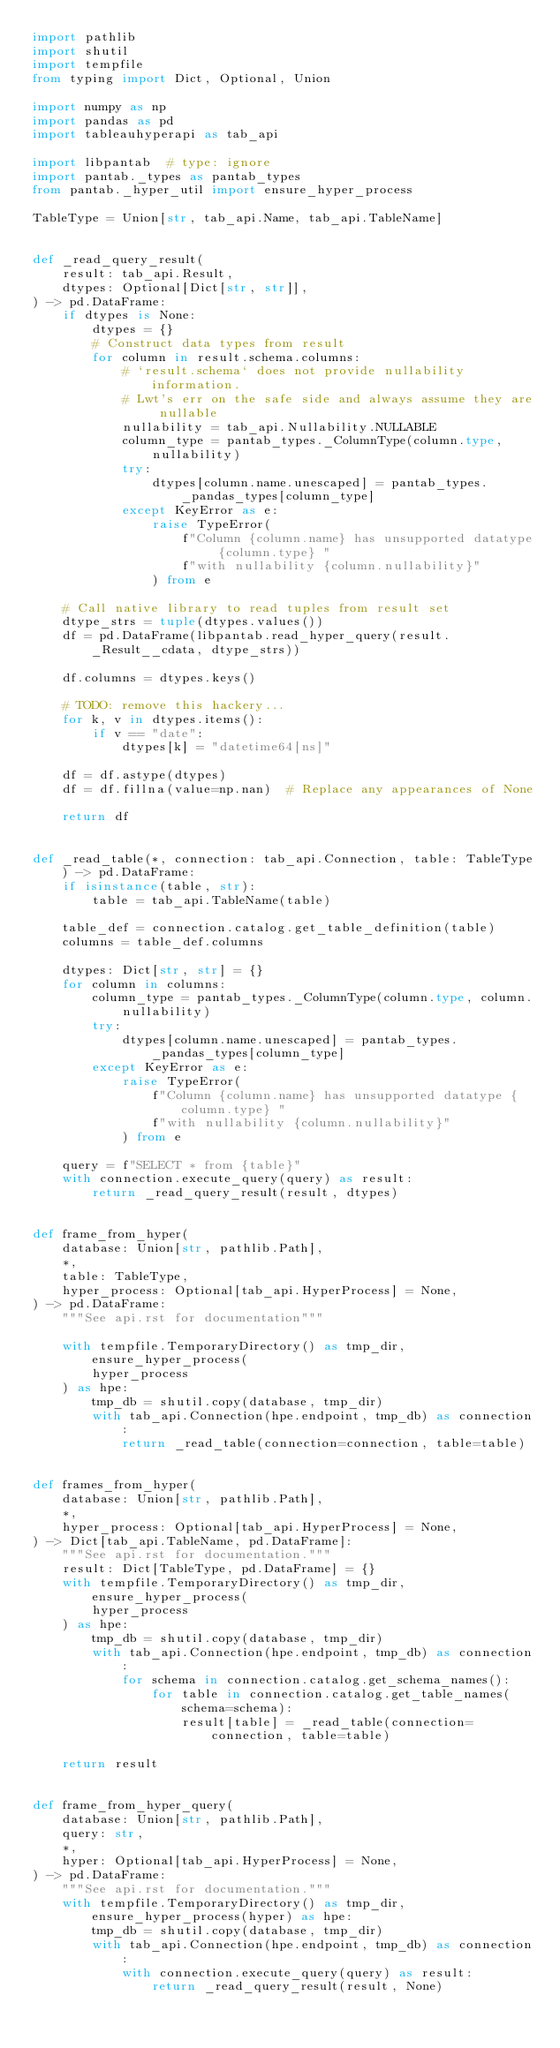Convert code to text. <code><loc_0><loc_0><loc_500><loc_500><_Python_>import pathlib
import shutil
import tempfile
from typing import Dict, Optional, Union

import numpy as np
import pandas as pd
import tableauhyperapi as tab_api

import libpantab  # type: ignore
import pantab._types as pantab_types
from pantab._hyper_util import ensure_hyper_process

TableType = Union[str, tab_api.Name, tab_api.TableName]


def _read_query_result(
    result: tab_api.Result,
    dtypes: Optional[Dict[str, str]],
) -> pd.DataFrame:
    if dtypes is None:
        dtypes = {}
        # Construct data types from result
        for column in result.schema.columns:
            # `result.schema` does not provide nullability information.
            # Lwt's err on the safe side and always assume they are nullable
            nullability = tab_api.Nullability.NULLABLE
            column_type = pantab_types._ColumnType(column.type, nullability)
            try:
                dtypes[column.name.unescaped] = pantab_types._pandas_types[column_type]
            except KeyError as e:
                raise TypeError(
                    f"Column {column.name} has unsupported datatype {column.type} "
                    f"with nullability {column.nullability}"
                ) from e

    # Call native library to read tuples from result set
    dtype_strs = tuple(dtypes.values())
    df = pd.DataFrame(libpantab.read_hyper_query(result._Result__cdata, dtype_strs))

    df.columns = dtypes.keys()

    # TODO: remove this hackery...
    for k, v in dtypes.items():
        if v == "date":
            dtypes[k] = "datetime64[ns]"

    df = df.astype(dtypes)
    df = df.fillna(value=np.nan)  # Replace any appearances of None

    return df


def _read_table(*, connection: tab_api.Connection, table: TableType) -> pd.DataFrame:
    if isinstance(table, str):
        table = tab_api.TableName(table)

    table_def = connection.catalog.get_table_definition(table)
    columns = table_def.columns

    dtypes: Dict[str, str] = {}
    for column in columns:
        column_type = pantab_types._ColumnType(column.type, column.nullability)
        try:
            dtypes[column.name.unescaped] = pantab_types._pandas_types[column_type]
        except KeyError as e:
            raise TypeError(
                f"Column {column.name} has unsupported datatype {column.type} "
                f"with nullability {column.nullability}"
            ) from e

    query = f"SELECT * from {table}"
    with connection.execute_query(query) as result:
        return _read_query_result(result, dtypes)


def frame_from_hyper(
    database: Union[str, pathlib.Path],
    *,
    table: TableType,
    hyper_process: Optional[tab_api.HyperProcess] = None,
) -> pd.DataFrame:
    """See api.rst for documentation"""

    with tempfile.TemporaryDirectory() as tmp_dir, ensure_hyper_process(
        hyper_process
    ) as hpe:
        tmp_db = shutil.copy(database, tmp_dir)
        with tab_api.Connection(hpe.endpoint, tmp_db) as connection:
            return _read_table(connection=connection, table=table)


def frames_from_hyper(
    database: Union[str, pathlib.Path],
    *,
    hyper_process: Optional[tab_api.HyperProcess] = None,
) -> Dict[tab_api.TableName, pd.DataFrame]:
    """See api.rst for documentation."""
    result: Dict[TableType, pd.DataFrame] = {}
    with tempfile.TemporaryDirectory() as tmp_dir, ensure_hyper_process(
        hyper_process
    ) as hpe:
        tmp_db = shutil.copy(database, tmp_dir)
        with tab_api.Connection(hpe.endpoint, tmp_db) as connection:
            for schema in connection.catalog.get_schema_names():
                for table in connection.catalog.get_table_names(schema=schema):
                    result[table] = _read_table(connection=connection, table=table)

    return result


def frame_from_hyper_query(
    database: Union[str, pathlib.Path],
    query: str,
    *,
    hyper: Optional[tab_api.HyperProcess] = None,
) -> pd.DataFrame:
    """See api.rst for documentation."""
    with tempfile.TemporaryDirectory() as tmp_dir, ensure_hyper_process(hyper) as hpe:
        tmp_db = shutil.copy(database, tmp_dir)
        with tab_api.Connection(hpe.endpoint, tmp_db) as connection:
            with connection.execute_query(query) as result:
                return _read_query_result(result, None)
</code> 